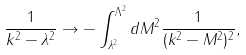<formula> <loc_0><loc_0><loc_500><loc_500>\frac { 1 } { k ^ { 2 } - \lambda ^ { 2 } } \rightarrow - \int _ { \lambda ^ { 2 } } ^ { \Lambda ^ { 2 } } d M ^ { 2 } \frac { 1 } { ( k ^ { 2 } - M ^ { 2 } ) ^ { 2 } } ,</formula> 